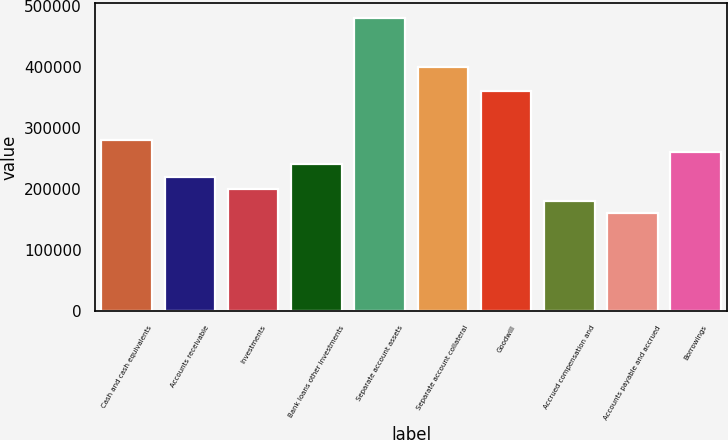Convert chart to OTSL. <chart><loc_0><loc_0><loc_500><loc_500><bar_chart><fcel>Cash and cash equivalents<fcel>Accounts receivable<fcel>Investments<fcel>Bank loans other investments<fcel>Separate account assets<fcel>Separate account collateral<fcel>Goodwill<fcel>Accrued compensation and<fcel>Accounts payable and accrued<fcel>Borrowings<nl><fcel>280631<fcel>220496<fcel>200451<fcel>240541<fcel>481080<fcel>400900<fcel>360810<fcel>180406<fcel>160361<fcel>260586<nl></chart> 